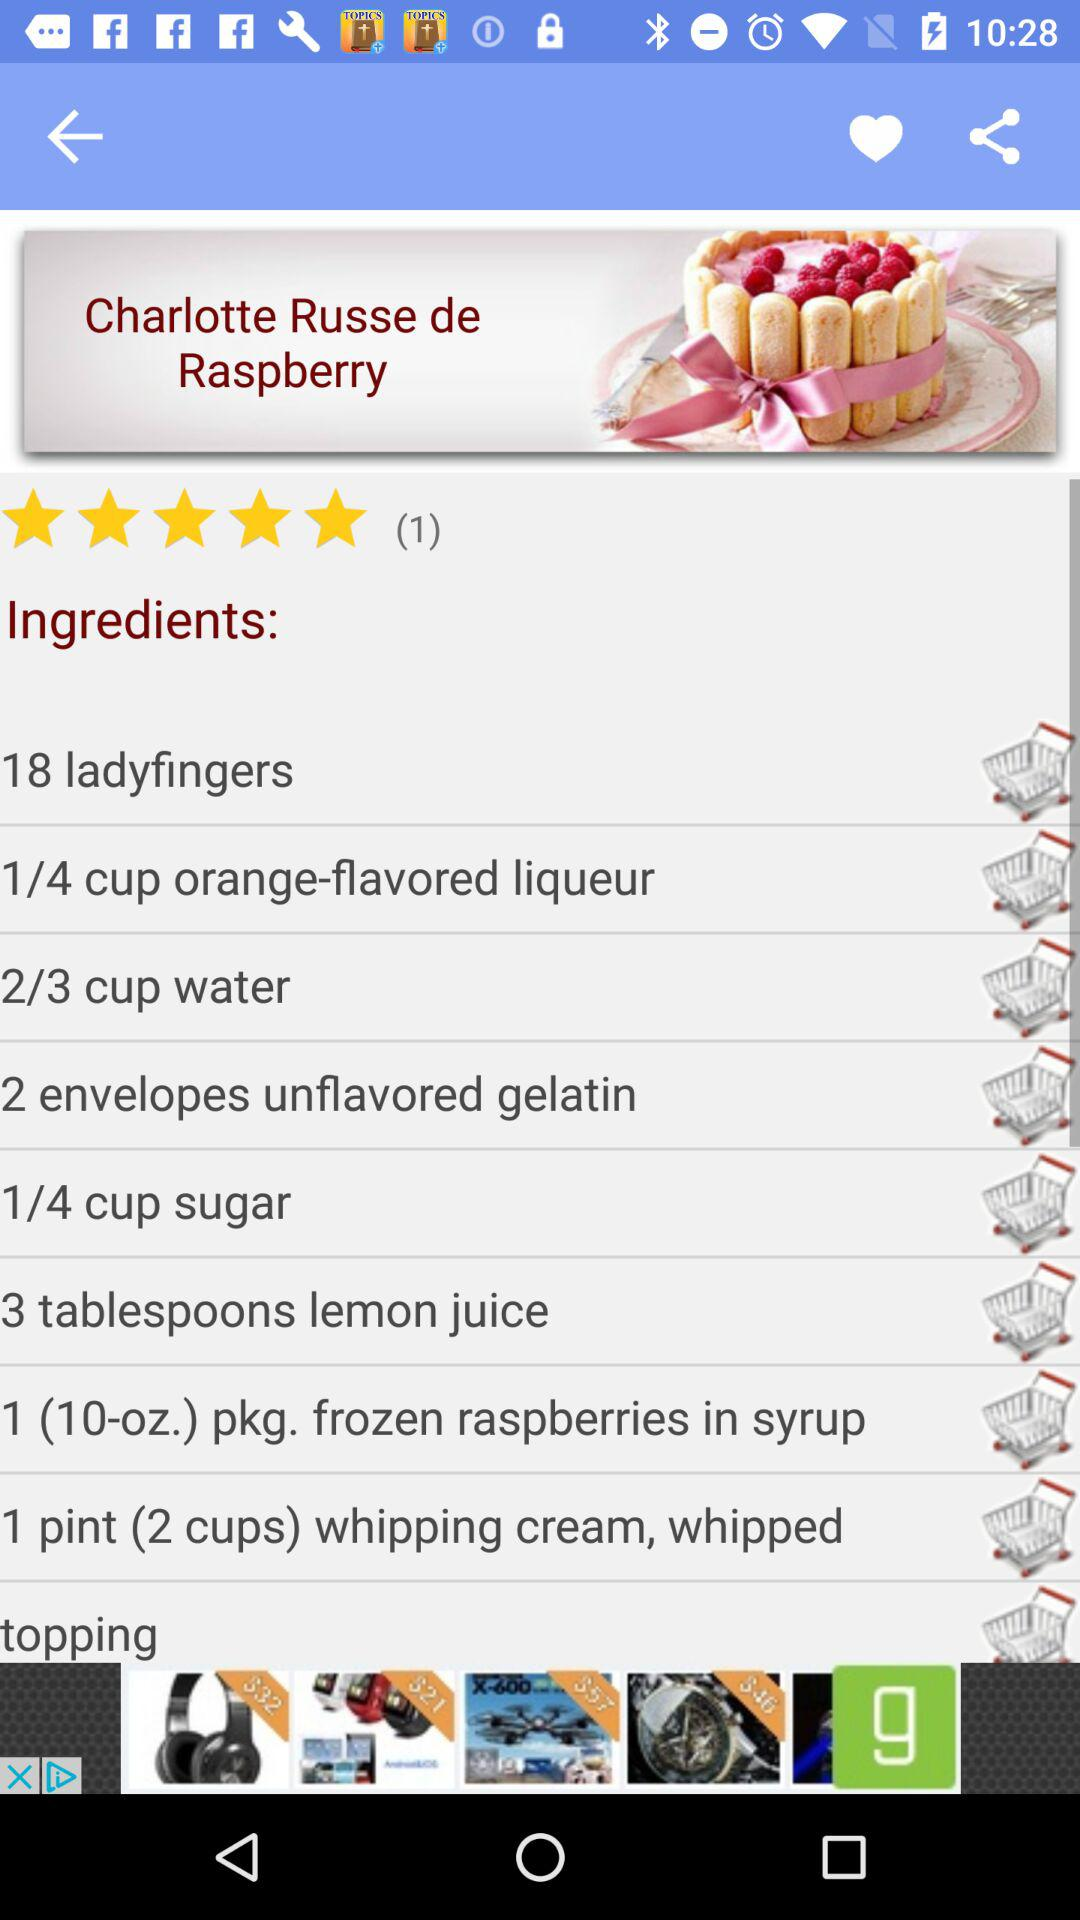Which item requires 3 tablespoons? The item that requires 3 tablespoons is "lemon juice". 